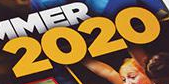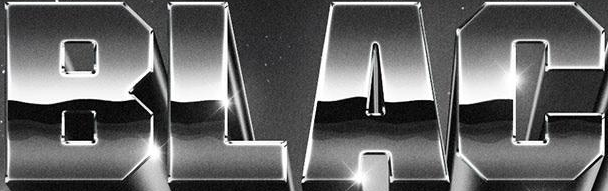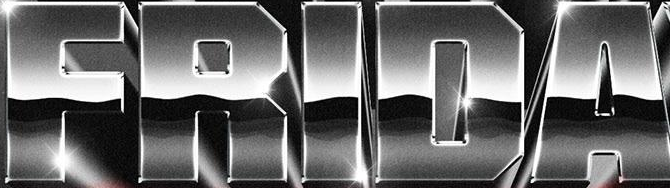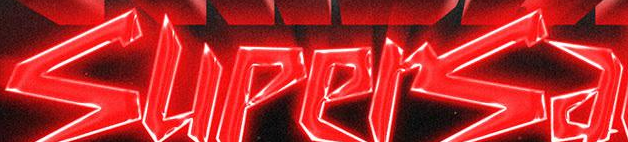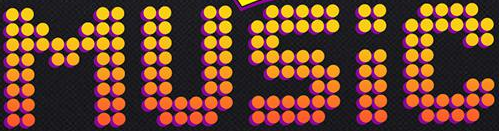What words can you see in these images in sequence, separated by a semicolon? 2020; BLAC; FRIDA; supersa; MUSIC 